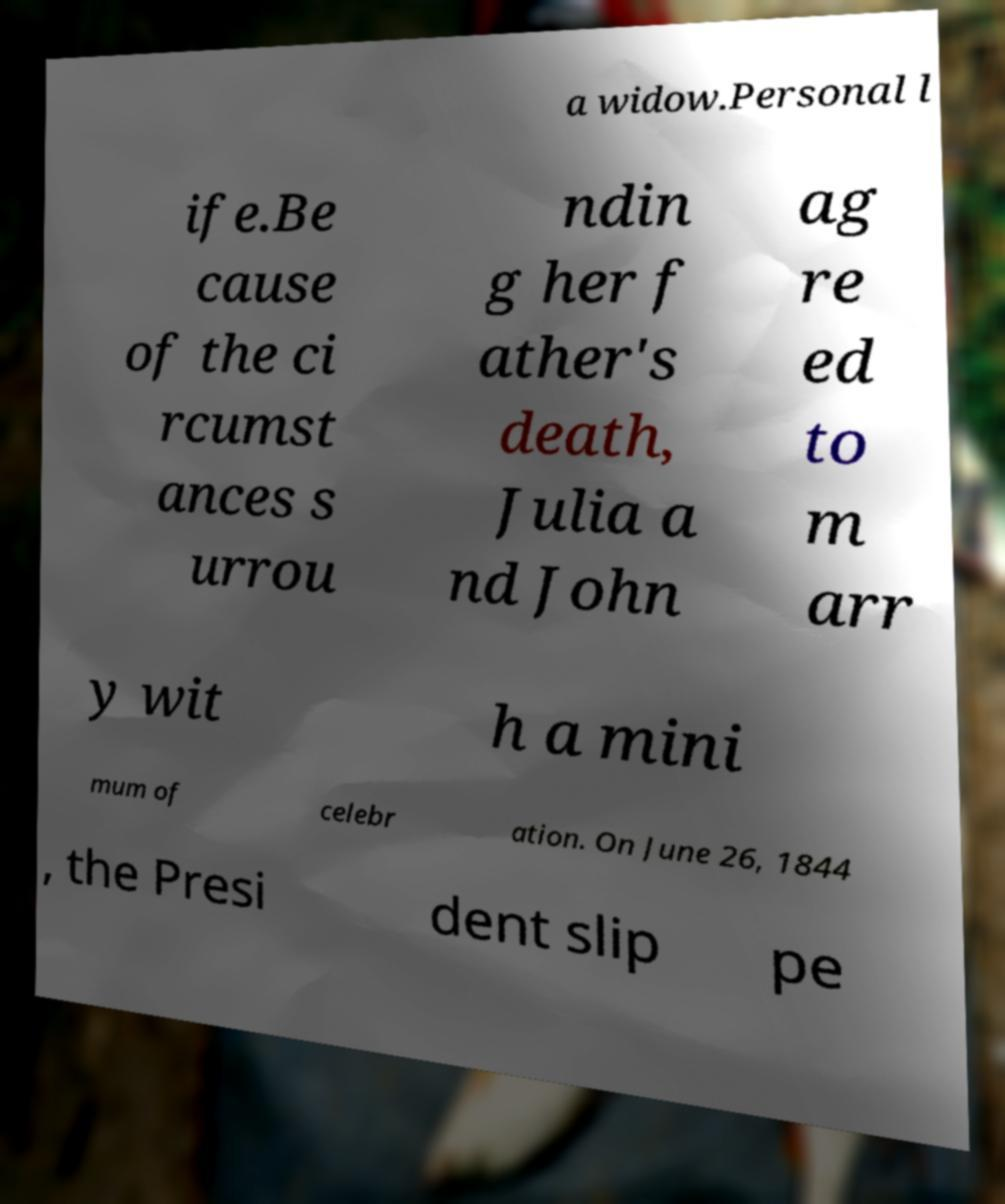Could you assist in decoding the text presented in this image and type it out clearly? a widow.Personal l ife.Be cause of the ci rcumst ances s urrou ndin g her f ather's death, Julia a nd John ag re ed to m arr y wit h a mini mum of celebr ation. On June 26, 1844 , the Presi dent slip pe 